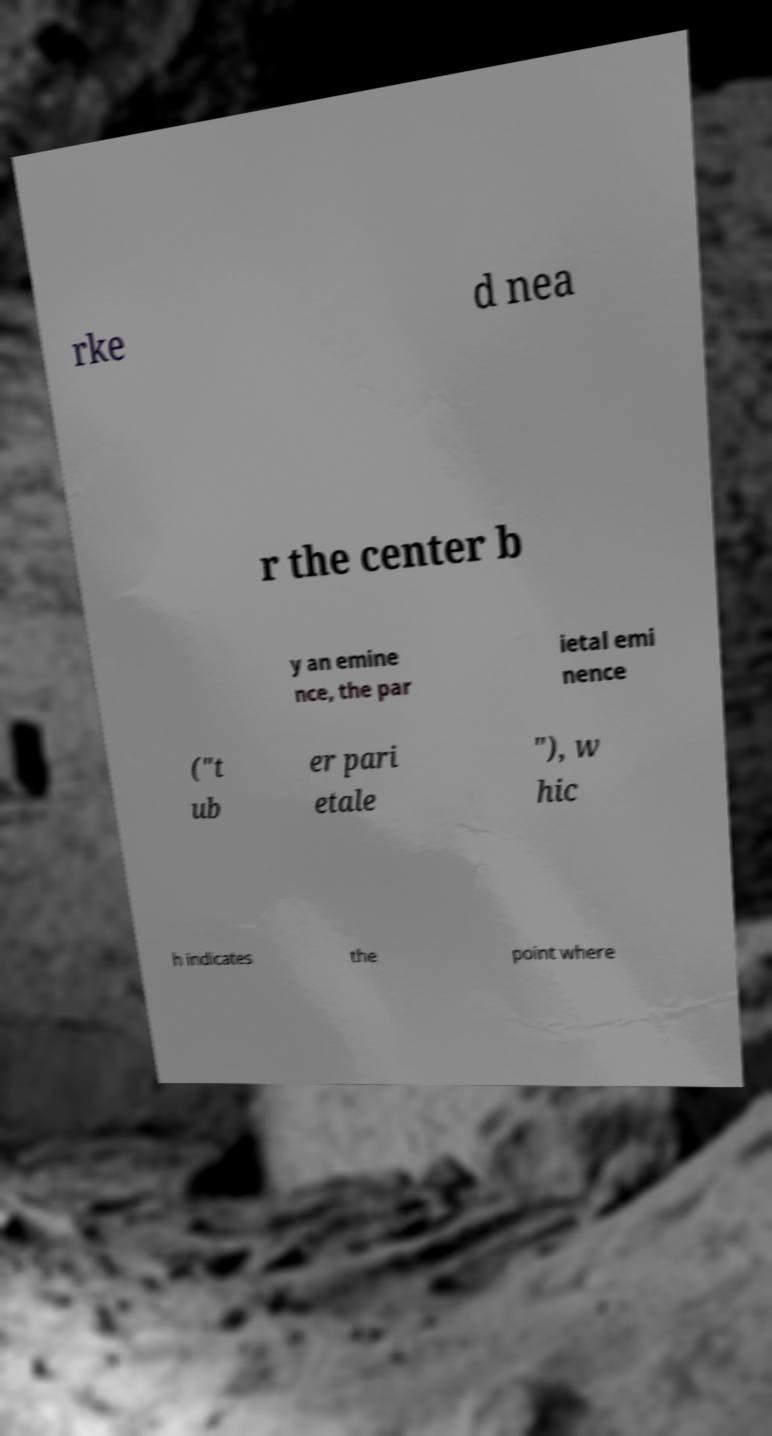There's text embedded in this image that I need extracted. Can you transcribe it verbatim? rke d nea r the center b y an emine nce, the par ietal emi nence ("t ub er pari etale "), w hic h indicates the point where 